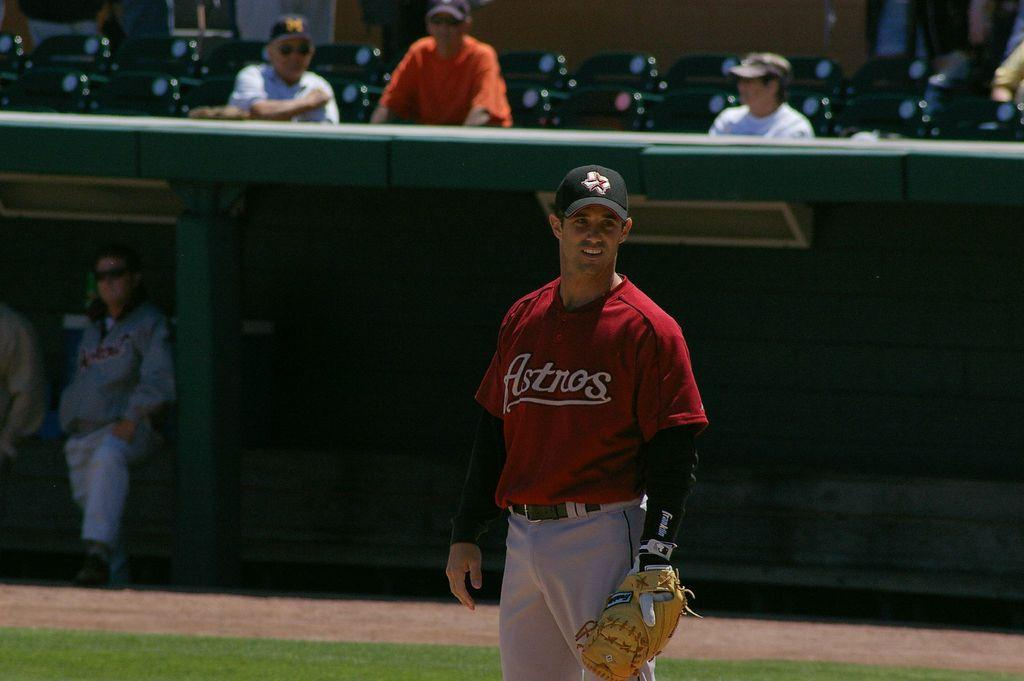<image>
Relay a brief, clear account of the picture shown. An Astros baseball player stands in the field looking at something afar. 